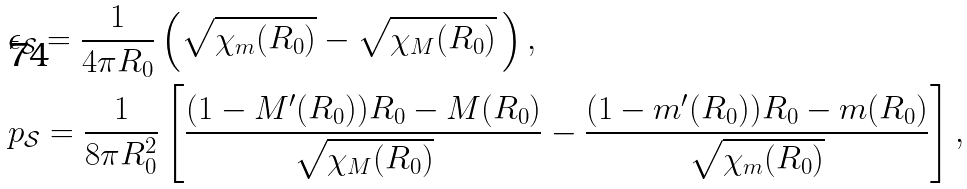Convert formula to latex. <formula><loc_0><loc_0><loc_500><loc_500>& \epsilon _ { \mathcal { S } } = \frac { 1 } { 4 \pi R _ { 0 } } \left ( \sqrt { \chi _ { m } ( R _ { 0 } ) } - \sqrt { \chi _ { M } ( R _ { 0 } ) } \, \right ) , \\ & p _ { \mathcal { S } } = \frac { 1 } { 8 \pi R _ { 0 } ^ { 2 } } \left [ \frac { ( 1 - M ^ { \prime } ( R _ { 0 } ) ) R _ { 0 } - M ( R _ { 0 } ) } { \sqrt { \chi _ { M } ( R _ { 0 } ) } } - \frac { ( 1 - m ^ { \prime } ( R _ { 0 } ) ) R _ { 0 } - m ( R _ { 0 } ) } { \sqrt { \chi _ { m } ( R _ { 0 } ) } } \right ] ,</formula> 